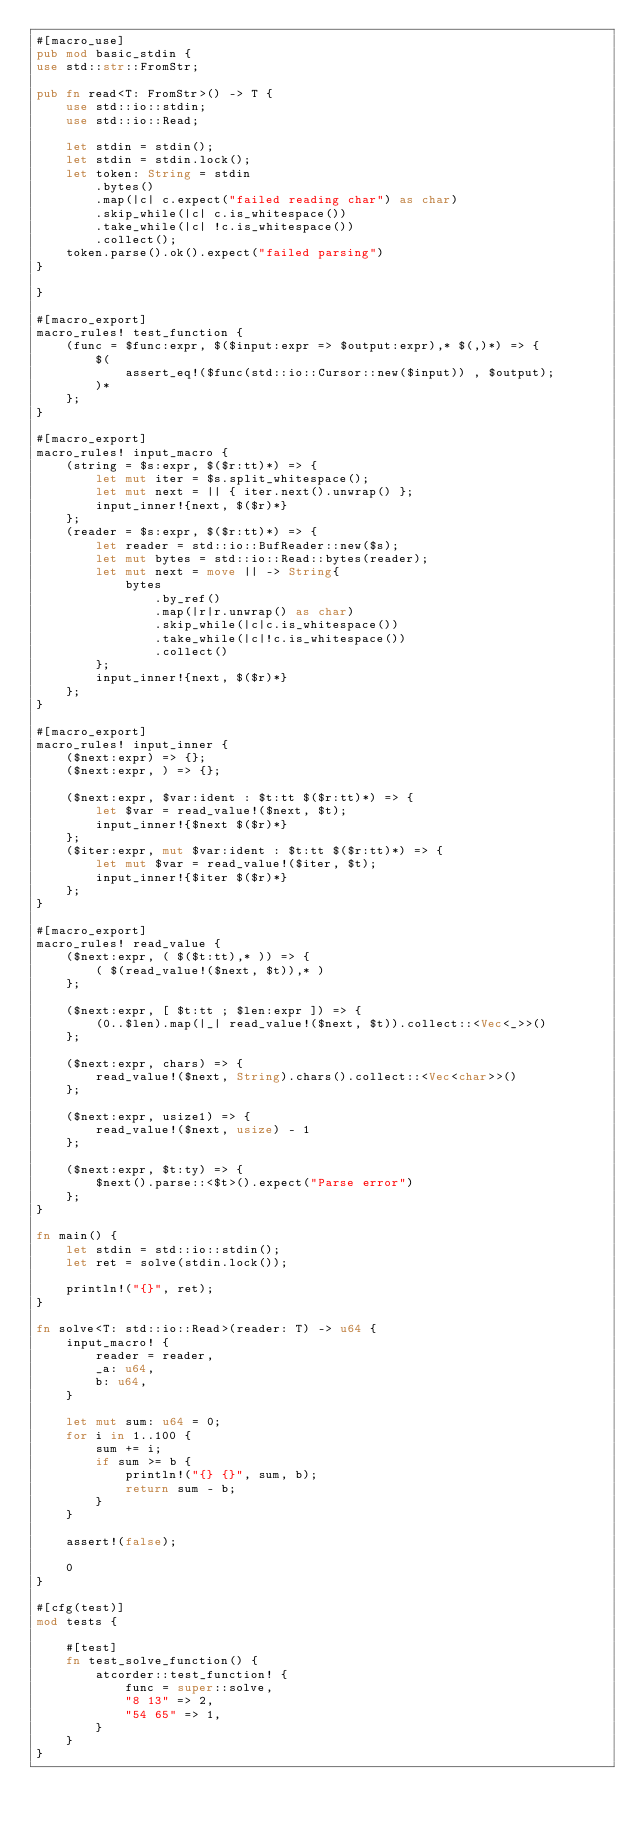Convert code to text. <code><loc_0><loc_0><loc_500><loc_500><_Rust_>#[macro_use]
pub mod basic_stdin {
use std::str::FromStr;

pub fn read<T: FromStr>() -> T {
    use std::io::stdin;
    use std::io::Read;

    let stdin = stdin();
    let stdin = stdin.lock();
    let token: String = stdin
        .bytes()
        .map(|c| c.expect("failed reading char") as char)
        .skip_while(|c| c.is_whitespace())
        .take_while(|c| !c.is_whitespace())
        .collect();
    token.parse().ok().expect("failed parsing")
}

}

#[macro_export]
macro_rules! test_function {
    (func = $func:expr, $($input:expr => $output:expr),* $(,)*) => {
        $(
            assert_eq!($func(std::io::Cursor::new($input)) , $output);
        )*
    };
}

#[macro_export]
macro_rules! input_macro {
    (string = $s:expr, $($r:tt)*) => {
        let mut iter = $s.split_whitespace();
        let mut next = || { iter.next().unwrap() };
        input_inner!{next, $($r)*}
    };
    (reader = $s:expr, $($r:tt)*) => {
        let reader = std::io::BufReader::new($s);
        let mut bytes = std::io::Read::bytes(reader);
        let mut next = move || -> String{
            bytes
                .by_ref()
                .map(|r|r.unwrap() as char)
                .skip_while(|c|c.is_whitespace())
                .take_while(|c|!c.is_whitespace())
                .collect()
        };
        input_inner!{next, $($r)*}
    };
}

#[macro_export]
macro_rules! input_inner {
    ($next:expr) => {};
    ($next:expr, ) => {};

    ($next:expr, $var:ident : $t:tt $($r:tt)*) => {
        let $var = read_value!($next, $t);
        input_inner!{$next $($r)*}
    };
    ($iter:expr, mut $var:ident : $t:tt $($r:tt)*) => {
        let mut $var = read_value!($iter, $t);
        input_inner!{$iter $($r)*}
    };
}

#[macro_export]
macro_rules! read_value {
    ($next:expr, ( $($t:tt),* )) => {
        ( $(read_value!($next, $t)),* )
    };

    ($next:expr, [ $t:tt ; $len:expr ]) => {
        (0..$len).map(|_| read_value!($next, $t)).collect::<Vec<_>>()
    };

    ($next:expr, chars) => {
        read_value!($next, String).chars().collect::<Vec<char>>()
    };

    ($next:expr, usize1) => {
        read_value!($next, usize) - 1
    };

    ($next:expr, $t:ty) => {
        $next().parse::<$t>().expect("Parse error")
    };
}

fn main() {
    let stdin = std::io::stdin();
    let ret = solve(stdin.lock());

    println!("{}", ret);
}

fn solve<T: std::io::Read>(reader: T) -> u64 {
    input_macro! {
        reader = reader,
        _a: u64,
        b: u64,
    }

    let mut sum: u64 = 0;
    for i in 1..100 {
        sum += i;
        if sum >= b {
            println!("{} {}", sum, b);
            return sum - b;
        }
    }

    assert!(false);

    0
}

#[cfg(test)]
mod tests {

    #[test]
    fn test_solve_function() {
        atcorder::test_function! {
            func = super::solve,
            "8 13" => 2,
            "54 65" => 1,
        }
    }
}
</code> 